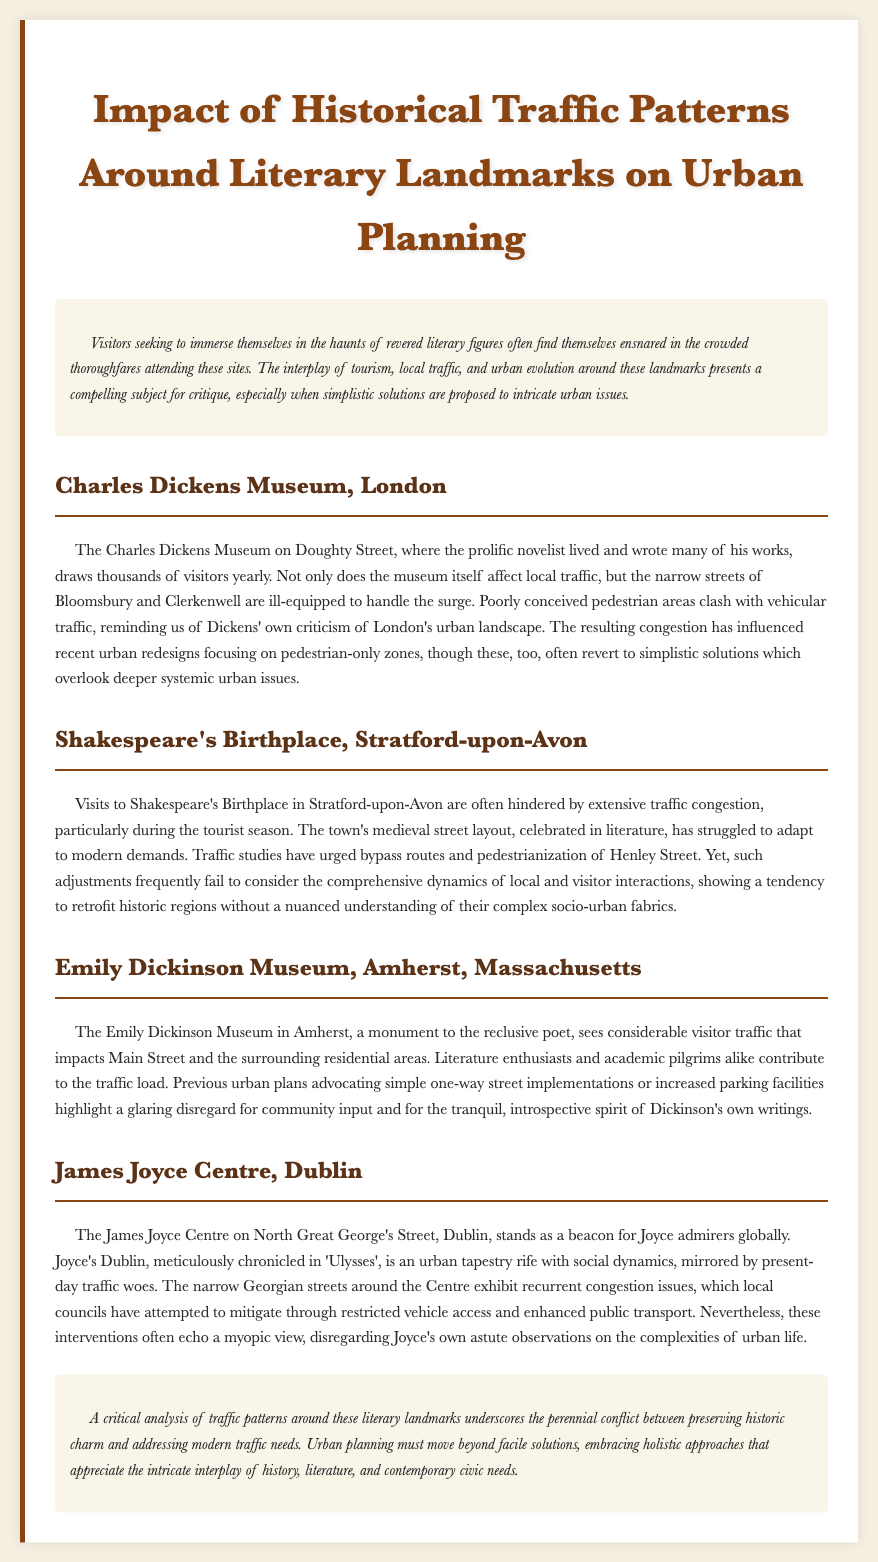What is the title of the report? The title of the report is clearly stated at the beginning of the document as "Impact of Historical Traffic Patterns Around Literary Landmarks on Urban Planning."
Answer: Impact of Historical Traffic Patterns Around Literary Landmarks on Urban Planning What is the address of the Charles Dickens Museum? The address given for the Charles Dickens Museum is Doughty Street.
Answer: Doughty Street Which literary figure is associated with the museum in Amherst, Massachusetts? The literary figure associated with the museum in Amherst is Emily Dickinson.
Answer: Emily Dickinson What traffic solution is suggested for Shakespeare's Birthplace? The suggested solution for Shakespeare's Birthplace includes the pedestrianization of Henley Street.
Answer: Pedestrianization of Henley Street Which city is home to the James Joyce Centre? The city mentioned for the James Joyce Centre is Dublin.
Answer: Dublin What is a common issue faced at Dickens Museum and Shakespeare's Birthplace? Both locations face the common issue of traffic congestion due to high visitor numbers.
Answer: Traffic congestion What style of urban planning is critiqued throughout the report? The report critiques simplistic solutions in urban planning that fail to consider deeper issues.
Answer: Simplistic solutions How do traffic patterns influence urban redesign according to the report? Traffic patterns have influenced urban redesign by pushing for pedestrian-only zones, although these often overlook systemic issues.
Answer: Pedestrian-only zones What does the report suggest about visitor interactions in Stratford-upon-Avon? The report suggests that adjustments in urban planning fail to consider comprehensive dynamics of local and visitor interactions.
Answer: Comprehensive dynamics of local and visitor interactions 